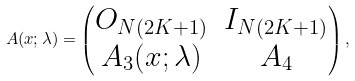<formula> <loc_0><loc_0><loc_500><loc_500>A ( x ; \lambda ) = \begin{pmatrix} O _ { N ( 2 K + 1 ) } & I _ { N ( 2 K + 1 ) } \\ A _ { 3 } ( x ; \lambda ) & A _ { 4 } \end{pmatrix} ,</formula> 